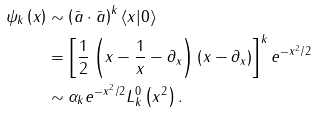Convert formula to latex. <formula><loc_0><loc_0><loc_500><loc_500>\psi _ { k } \left ( x \right ) & \sim \left ( \bar { a } \cdot \bar { a } \right ) ^ { k } \langle x | 0 \rangle \\ & = \left [ \frac { 1 } { 2 } \left ( x - \frac { 1 } { x } - \partial _ { x } \right ) \left ( x - \partial _ { x } \right ) \right ] ^ { k } e ^ { - x ^ { 2 } / 2 } \\ & \sim \alpha _ { k } e ^ { - x ^ { 2 } / 2 } L _ { k } ^ { 0 } \left ( x ^ { 2 } \right ) .</formula> 